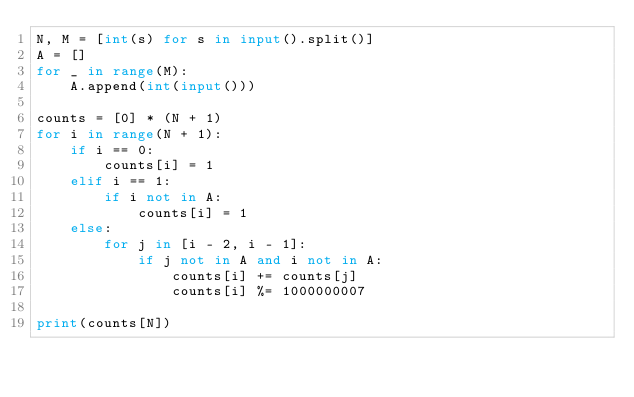Convert code to text. <code><loc_0><loc_0><loc_500><loc_500><_Python_>N, M = [int(s) for s in input().split()]
A = []
for _ in range(M):
    A.append(int(input()))

counts = [0] * (N + 1)
for i in range(N + 1):
    if i == 0:
        counts[i] = 1
    elif i == 1:
        if i not in A:
            counts[i] = 1
    else:
        for j in [i - 2, i - 1]:
            if j not in A and i not in A:
                counts[i] += counts[j]
                counts[i] %= 1000000007

print(counts[N])
</code> 